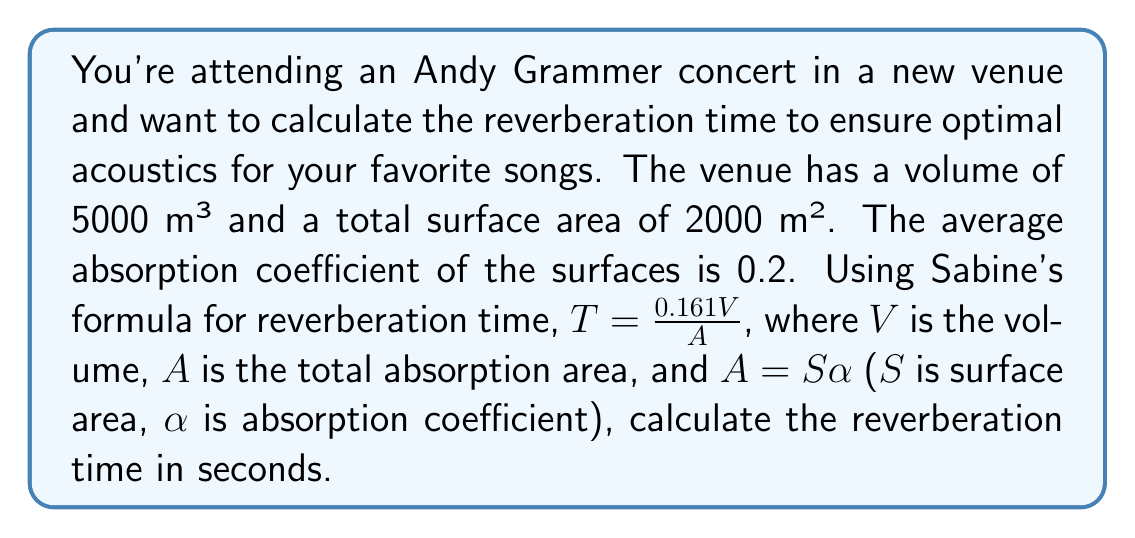Could you help me with this problem? To solve this problem, we'll follow these steps:

1) First, recall Sabine's formula for reverberation time:

   $$T = \frac{0.161V}{A}$$

   Where:
   $T$ = reverberation time (s)
   $V$ = volume of the room (m³)
   $A$ = total absorption area (m²)

2) We're given:
   $V = 5000$ m³
   $S$ (total surface area) = 2000 m²
   $\alpha$ (average absorption coefficient) = 0.2

3) Calculate the total absorption area $A$:
   $$A = S\alpha = 2000 \times 0.2 = 400 \text{ m²}$$

4) Now we can substitute these values into Sabine's formula:

   $$T = \frac{0.161 \times 5000}{400}$$

5) Simplify:
   $$T = \frac{805}{400} = 2.0125 \text{ seconds}$$

Thus, the reverberation time in the concert venue is approximately 2.01 seconds.
Answer: 2.01 seconds 